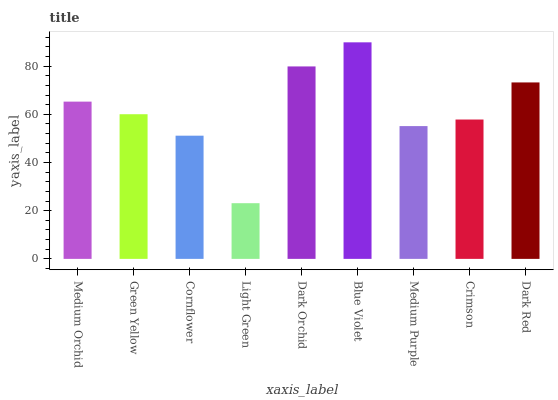Is Light Green the minimum?
Answer yes or no. Yes. Is Blue Violet the maximum?
Answer yes or no. Yes. Is Green Yellow the minimum?
Answer yes or no. No. Is Green Yellow the maximum?
Answer yes or no. No. Is Medium Orchid greater than Green Yellow?
Answer yes or no. Yes. Is Green Yellow less than Medium Orchid?
Answer yes or no. Yes. Is Green Yellow greater than Medium Orchid?
Answer yes or no. No. Is Medium Orchid less than Green Yellow?
Answer yes or no. No. Is Green Yellow the high median?
Answer yes or no. Yes. Is Green Yellow the low median?
Answer yes or no. Yes. Is Medium Purple the high median?
Answer yes or no. No. Is Cornflower the low median?
Answer yes or no. No. 